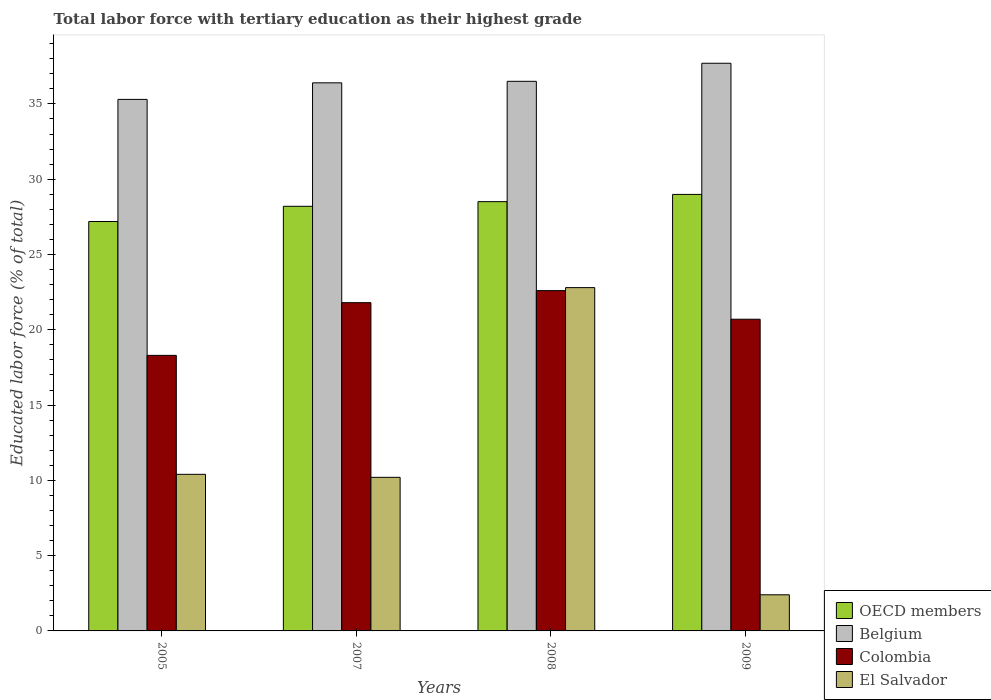How many different coloured bars are there?
Make the answer very short. 4. How many groups of bars are there?
Offer a terse response. 4. Are the number of bars on each tick of the X-axis equal?
Your answer should be very brief. Yes. How many bars are there on the 2nd tick from the left?
Offer a terse response. 4. How many bars are there on the 1st tick from the right?
Offer a terse response. 4. What is the percentage of male labor force with tertiary education in Colombia in 2008?
Give a very brief answer. 22.6. Across all years, what is the maximum percentage of male labor force with tertiary education in Colombia?
Offer a terse response. 22.6. Across all years, what is the minimum percentage of male labor force with tertiary education in Colombia?
Your answer should be compact. 18.3. In which year was the percentage of male labor force with tertiary education in Belgium maximum?
Give a very brief answer. 2009. In which year was the percentage of male labor force with tertiary education in El Salvador minimum?
Provide a short and direct response. 2009. What is the total percentage of male labor force with tertiary education in El Salvador in the graph?
Your answer should be very brief. 45.8. What is the difference between the percentage of male labor force with tertiary education in OECD members in 2005 and that in 2007?
Offer a terse response. -1.01. What is the difference between the percentage of male labor force with tertiary education in OECD members in 2007 and the percentage of male labor force with tertiary education in Colombia in 2008?
Offer a very short reply. 5.6. What is the average percentage of male labor force with tertiary education in Colombia per year?
Your answer should be very brief. 20.85. In the year 2009, what is the difference between the percentage of male labor force with tertiary education in Colombia and percentage of male labor force with tertiary education in OECD members?
Offer a very short reply. -8.29. In how many years, is the percentage of male labor force with tertiary education in Colombia greater than 5 %?
Offer a terse response. 4. What is the ratio of the percentage of male labor force with tertiary education in El Salvador in 2007 to that in 2009?
Give a very brief answer. 4.25. Is the percentage of male labor force with tertiary education in Colombia in 2007 less than that in 2008?
Provide a succinct answer. Yes. Is the difference between the percentage of male labor force with tertiary education in Colombia in 2007 and 2008 greater than the difference between the percentage of male labor force with tertiary education in OECD members in 2007 and 2008?
Keep it short and to the point. No. What is the difference between the highest and the second highest percentage of male labor force with tertiary education in Colombia?
Your answer should be very brief. 0.8. What is the difference between the highest and the lowest percentage of male labor force with tertiary education in El Salvador?
Offer a terse response. 20.4. Is the sum of the percentage of male labor force with tertiary education in Belgium in 2008 and 2009 greater than the maximum percentage of male labor force with tertiary education in Colombia across all years?
Provide a short and direct response. Yes. What does the 4th bar from the right in 2008 represents?
Your answer should be very brief. OECD members. How many bars are there?
Provide a succinct answer. 16. What is the difference between two consecutive major ticks on the Y-axis?
Provide a short and direct response. 5. Are the values on the major ticks of Y-axis written in scientific E-notation?
Your answer should be very brief. No. Where does the legend appear in the graph?
Provide a succinct answer. Bottom right. How are the legend labels stacked?
Make the answer very short. Vertical. What is the title of the graph?
Provide a short and direct response. Total labor force with tertiary education as their highest grade. Does "Morocco" appear as one of the legend labels in the graph?
Ensure brevity in your answer.  No. What is the label or title of the Y-axis?
Your answer should be compact. Educated labor force (% of total). What is the Educated labor force (% of total) of OECD members in 2005?
Provide a short and direct response. 27.19. What is the Educated labor force (% of total) in Belgium in 2005?
Your answer should be compact. 35.3. What is the Educated labor force (% of total) of Colombia in 2005?
Provide a short and direct response. 18.3. What is the Educated labor force (% of total) of El Salvador in 2005?
Give a very brief answer. 10.4. What is the Educated labor force (% of total) in OECD members in 2007?
Your response must be concise. 28.2. What is the Educated labor force (% of total) of Belgium in 2007?
Provide a short and direct response. 36.4. What is the Educated labor force (% of total) in Colombia in 2007?
Your answer should be very brief. 21.8. What is the Educated labor force (% of total) in El Salvador in 2007?
Keep it short and to the point. 10.2. What is the Educated labor force (% of total) in OECD members in 2008?
Offer a very short reply. 28.51. What is the Educated labor force (% of total) in Belgium in 2008?
Offer a terse response. 36.5. What is the Educated labor force (% of total) of Colombia in 2008?
Give a very brief answer. 22.6. What is the Educated labor force (% of total) in El Salvador in 2008?
Give a very brief answer. 22.8. What is the Educated labor force (% of total) in OECD members in 2009?
Provide a succinct answer. 28.99. What is the Educated labor force (% of total) of Belgium in 2009?
Offer a terse response. 37.7. What is the Educated labor force (% of total) in Colombia in 2009?
Your answer should be very brief. 20.7. What is the Educated labor force (% of total) in El Salvador in 2009?
Your answer should be compact. 2.4. Across all years, what is the maximum Educated labor force (% of total) of OECD members?
Provide a succinct answer. 28.99. Across all years, what is the maximum Educated labor force (% of total) of Belgium?
Your answer should be compact. 37.7. Across all years, what is the maximum Educated labor force (% of total) of Colombia?
Your response must be concise. 22.6. Across all years, what is the maximum Educated labor force (% of total) in El Salvador?
Provide a succinct answer. 22.8. Across all years, what is the minimum Educated labor force (% of total) of OECD members?
Make the answer very short. 27.19. Across all years, what is the minimum Educated labor force (% of total) of Belgium?
Provide a succinct answer. 35.3. Across all years, what is the minimum Educated labor force (% of total) of Colombia?
Your answer should be compact. 18.3. Across all years, what is the minimum Educated labor force (% of total) of El Salvador?
Make the answer very short. 2.4. What is the total Educated labor force (% of total) of OECD members in the graph?
Keep it short and to the point. 112.89. What is the total Educated labor force (% of total) in Belgium in the graph?
Offer a terse response. 145.9. What is the total Educated labor force (% of total) in Colombia in the graph?
Keep it short and to the point. 83.4. What is the total Educated labor force (% of total) in El Salvador in the graph?
Make the answer very short. 45.8. What is the difference between the Educated labor force (% of total) of OECD members in 2005 and that in 2007?
Your answer should be very brief. -1.01. What is the difference between the Educated labor force (% of total) of Belgium in 2005 and that in 2007?
Keep it short and to the point. -1.1. What is the difference between the Educated labor force (% of total) in Colombia in 2005 and that in 2007?
Your answer should be very brief. -3.5. What is the difference between the Educated labor force (% of total) of OECD members in 2005 and that in 2008?
Make the answer very short. -1.32. What is the difference between the Educated labor force (% of total) in Belgium in 2005 and that in 2008?
Make the answer very short. -1.2. What is the difference between the Educated labor force (% of total) in El Salvador in 2005 and that in 2008?
Ensure brevity in your answer.  -12.4. What is the difference between the Educated labor force (% of total) of OECD members in 2005 and that in 2009?
Offer a terse response. -1.8. What is the difference between the Educated labor force (% of total) in Colombia in 2005 and that in 2009?
Provide a short and direct response. -2.4. What is the difference between the Educated labor force (% of total) in OECD members in 2007 and that in 2008?
Ensure brevity in your answer.  -0.31. What is the difference between the Educated labor force (% of total) of Colombia in 2007 and that in 2008?
Your answer should be very brief. -0.8. What is the difference between the Educated labor force (% of total) of OECD members in 2007 and that in 2009?
Make the answer very short. -0.79. What is the difference between the Educated labor force (% of total) in Colombia in 2007 and that in 2009?
Make the answer very short. 1.1. What is the difference between the Educated labor force (% of total) of OECD members in 2008 and that in 2009?
Give a very brief answer. -0.48. What is the difference between the Educated labor force (% of total) in Colombia in 2008 and that in 2009?
Your answer should be compact. 1.9. What is the difference between the Educated labor force (% of total) of El Salvador in 2008 and that in 2009?
Give a very brief answer. 20.4. What is the difference between the Educated labor force (% of total) of OECD members in 2005 and the Educated labor force (% of total) of Belgium in 2007?
Make the answer very short. -9.21. What is the difference between the Educated labor force (% of total) of OECD members in 2005 and the Educated labor force (% of total) of Colombia in 2007?
Give a very brief answer. 5.39. What is the difference between the Educated labor force (% of total) in OECD members in 2005 and the Educated labor force (% of total) in El Salvador in 2007?
Keep it short and to the point. 16.99. What is the difference between the Educated labor force (% of total) in Belgium in 2005 and the Educated labor force (% of total) in Colombia in 2007?
Ensure brevity in your answer.  13.5. What is the difference between the Educated labor force (% of total) of Belgium in 2005 and the Educated labor force (% of total) of El Salvador in 2007?
Keep it short and to the point. 25.1. What is the difference between the Educated labor force (% of total) in Colombia in 2005 and the Educated labor force (% of total) in El Salvador in 2007?
Keep it short and to the point. 8.1. What is the difference between the Educated labor force (% of total) of OECD members in 2005 and the Educated labor force (% of total) of Belgium in 2008?
Your answer should be compact. -9.31. What is the difference between the Educated labor force (% of total) of OECD members in 2005 and the Educated labor force (% of total) of Colombia in 2008?
Offer a very short reply. 4.59. What is the difference between the Educated labor force (% of total) in OECD members in 2005 and the Educated labor force (% of total) in El Salvador in 2008?
Keep it short and to the point. 4.39. What is the difference between the Educated labor force (% of total) of OECD members in 2005 and the Educated labor force (% of total) of Belgium in 2009?
Provide a short and direct response. -10.51. What is the difference between the Educated labor force (% of total) in OECD members in 2005 and the Educated labor force (% of total) in Colombia in 2009?
Keep it short and to the point. 6.49. What is the difference between the Educated labor force (% of total) in OECD members in 2005 and the Educated labor force (% of total) in El Salvador in 2009?
Your answer should be very brief. 24.79. What is the difference between the Educated labor force (% of total) of Belgium in 2005 and the Educated labor force (% of total) of El Salvador in 2009?
Keep it short and to the point. 32.9. What is the difference between the Educated labor force (% of total) of Colombia in 2005 and the Educated labor force (% of total) of El Salvador in 2009?
Keep it short and to the point. 15.9. What is the difference between the Educated labor force (% of total) in OECD members in 2007 and the Educated labor force (% of total) in Belgium in 2008?
Your answer should be very brief. -8.3. What is the difference between the Educated labor force (% of total) of OECD members in 2007 and the Educated labor force (% of total) of Colombia in 2008?
Your answer should be very brief. 5.6. What is the difference between the Educated labor force (% of total) of OECD members in 2007 and the Educated labor force (% of total) of El Salvador in 2008?
Your answer should be compact. 5.4. What is the difference between the Educated labor force (% of total) in Belgium in 2007 and the Educated labor force (% of total) in El Salvador in 2008?
Offer a very short reply. 13.6. What is the difference between the Educated labor force (% of total) in OECD members in 2007 and the Educated labor force (% of total) in Belgium in 2009?
Ensure brevity in your answer.  -9.5. What is the difference between the Educated labor force (% of total) in OECD members in 2007 and the Educated labor force (% of total) in Colombia in 2009?
Offer a terse response. 7.5. What is the difference between the Educated labor force (% of total) in OECD members in 2007 and the Educated labor force (% of total) in El Salvador in 2009?
Your answer should be very brief. 25.8. What is the difference between the Educated labor force (% of total) in Belgium in 2007 and the Educated labor force (% of total) in El Salvador in 2009?
Offer a very short reply. 34. What is the difference between the Educated labor force (% of total) in OECD members in 2008 and the Educated labor force (% of total) in Belgium in 2009?
Provide a succinct answer. -9.19. What is the difference between the Educated labor force (% of total) of OECD members in 2008 and the Educated labor force (% of total) of Colombia in 2009?
Provide a succinct answer. 7.81. What is the difference between the Educated labor force (% of total) in OECD members in 2008 and the Educated labor force (% of total) in El Salvador in 2009?
Make the answer very short. 26.11. What is the difference between the Educated labor force (% of total) of Belgium in 2008 and the Educated labor force (% of total) of El Salvador in 2009?
Offer a terse response. 34.1. What is the difference between the Educated labor force (% of total) of Colombia in 2008 and the Educated labor force (% of total) of El Salvador in 2009?
Provide a succinct answer. 20.2. What is the average Educated labor force (% of total) in OECD members per year?
Offer a very short reply. 28.22. What is the average Educated labor force (% of total) in Belgium per year?
Your response must be concise. 36.48. What is the average Educated labor force (% of total) in Colombia per year?
Your answer should be compact. 20.85. What is the average Educated labor force (% of total) of El Salvador per year?
Your answer should be compact. 11.45. In the year 2005, what is the difference between the Educated labor force (% of total) of OECD members and Educated labor force (% of total) of Belgium?
Provide a short and direct response. -8.11. In the year 2005, what is the difference between the Educated labor force (% of total) in OECD members and Educated labor force (% of total) in Colombia?
Your answer should be very brief. 8.89. In the year 2005, what is the difference between the Educated labor force (% of total) of OECD members and Educated labor force (% of total) of El Salvador?
Your answer should be very brief. 16.79. In the year 2005, what is the difference between the Educated labor force (% of total) of Belgium and Educated labor force (% of total) of Colombia?
Provide a succinct answer. 17. In the year 2005, what is the difference between the Educated labor force (% of total) of Belgium and Educated labor force (% of total) of El Salvador?
Provide a short and direct response. 24.9. In the year 2007, what is the difference between the Educated labor force (% of total) in OECD members and Educated labor force (% of total) in Belgium?
Your answer should be very brief. -8.2. In the year 2007, what is the difference between the Educated labor force (% of total) of OECD members and Educated labor force (% of total) of Colombia?
Your answer should be compact. 6.4. In the year 2007, what is the difference between the Educated labor force (% of total) in OECD members and Educated labor force (% of total) in El Salvador?
Make the answer very short. 18. In the year 2007, what is the difference between the Educated labor force (% of total) in Belgium and Educated labor force (% of total) in El Salvador?
Offer a very short reply. 26.2. In the year 2008, what is the difference between the Educated labor force (% of total) in OECD members and Educated labor force (% of total) in Belgium?
Provide a short and direct response. -7.99. In the year 2008, what is the difference between the Educated labor force (% of total) of OECD members and Educated labor force (% of total) of Colombia?
Your response must be concise. 5.91. In the year 2008, what is the difference between the Educated labor force (% of total) of OECD members and Educated labor force (% of total) of El Salvador?
Make the answer very short. 5.71. In the year 2008, what is the difference between the Educated labor force (% of total) of Belgium and Educated labor force (% of total) of Colombia?
Offer a very short reply. 13.9. In the year 2009, what is the difference between the Educated labor force (% of total) of OECD members and Educated labor force (% of total) of Belgium?
Offer a very short reply. -8.71. In the year 2009, what is the difference between the Educated labor force (% of total) in OECD members and Educated labor force (% of total) in Colombia?
Keep it short and to the point. 8.29. In the year 2009, what is the difference between the Educated labor force (% of total) of OECD members and Educated labor force (% of total) of El Salvador?
Offer a very short reply. 26.59. In the year 2009, what is the difference between the Educated labor force (% of total) of Belgium and Educated labor force (% of total) of El Salvador?
Ensure brevity in your answer.  35.3. What is the ratio of the Educated labor force (% of total) of OECD members in 2005 to that in 2007?
Give a very brief answer. 0.96. What is the ratio of the Educated labor force (% of total) in Belgium in 2005 to that in 2007?
Your answer should be compact. 0.97. What is the ratio of the Educated labor force (% of total) in Colombia in 2005 to that in 2007?
Give a very brief answer. 0.84. What is the ratio of the Educated labor force (% of total) in El Salvador in 2005 to that in 2007?
Your answer should be very brief. 1.02. What is the ratio of the Educated labor force (% of total) in OECD members in 2005 to that in 2008?
Offer a very short reply. 0.95. What is the ratio of the Educated labor force (% of total) of Belgium in 2005 to that in 2008?
Your response must be concise. 0.97. What is the ratio of the Educated labor force (% of total) of Colombia in 2005 to that in 2008?
Your response must be concise. 0.81. What is the ratio of the Educated labor force (% of total) of El Salvador in 2005 to that in 2008?
Provide a succinct answer. 0.46. What is the ratio of the Educated labor force (% of total) in OECD members in 2005 to that in 2009?
Your response must be concise. 0.94. What is the ratio of the Educated labor force (% of total) of Belgium in 2005 to that in 2009?
Provide a succinct answer. 0.94. What is the ratio of the Educated labor force (% of total) in Colombia in 2005 to that in 2009?
Give a very brief answer. 0.88. What is the ratio of the Educated labor force (% of total) of El Salvador in 2005 to that in 2009?
Provide a succinct answer. 4.33. What is the ratio of the Educated labor force (% of total) in Colombia in 2007 to that in 2008?
Give a very brief answer. 0.96. What is the ratio of the Educated labor force (% of total) in El Salvador in 2007 to that in 2008?
Offer a terse response. 0.45. What is the ratio of the Educated labor force (% of total) in OECD members in 2007 to that in 2009?
Make the answer very short. 0.97. What is the ratio of the Educated labor force (% of total) of Belgium in 2007 to that in 2009?
Ensure brevity in your answer.  0.97. What is the ratio of the Educated labor force (% of total) in Colombia in 2007 to that in 2009?
Provide a short and direct response. 1.05. What is the ratio of the Educated labor force (% of total) of El Salvador in 2007 to that in 2009?
Give a very brief answer. 4.25. What is the ratio of the Educated labor force (% of total) of OECD members in 2008 to that in 2009?
Offer a very short reply. 0.98. What is the ratio of the Educated labor force (% of total) in Belgium in 2008 to that in 2009?
Your answer should be compact. 0.97. What is the ratio of the Educated labor force (% of total) of Colombia in 2008 to that in 2009?
Your answer should be compact. 1.09. What is the ratio of the Educated labor force (% of total) of El Salvador in 2008 to that in 2009?
Provide a short and direct response. 9.5. What is the difference between the highest and the second highest Educated labor force (% of total) of OECD members?
Give a very brief answer. 0.48. What is the difference between the highest and the second highest Educated labor force (% of total) in Belgium?
Offer a terse response. 1.2. What is the difference between the highest and the second highest Educated labor force (% of total) in Colombia?
Provide a succinct answer. 0.8. What is the difference between the highest and the second highest Educated labor force (% of total) of El Salvador?
Offer a terse response. 12.4. What is the difference between the highest and the lowest Educated labor force (% of total) of OECD members?
Provide a succinct answer. 1.8. What is the difference between the highest and the lowest Educated labor force (% of total) of El Salvador?
Keep it short and to the point. 20.4. 